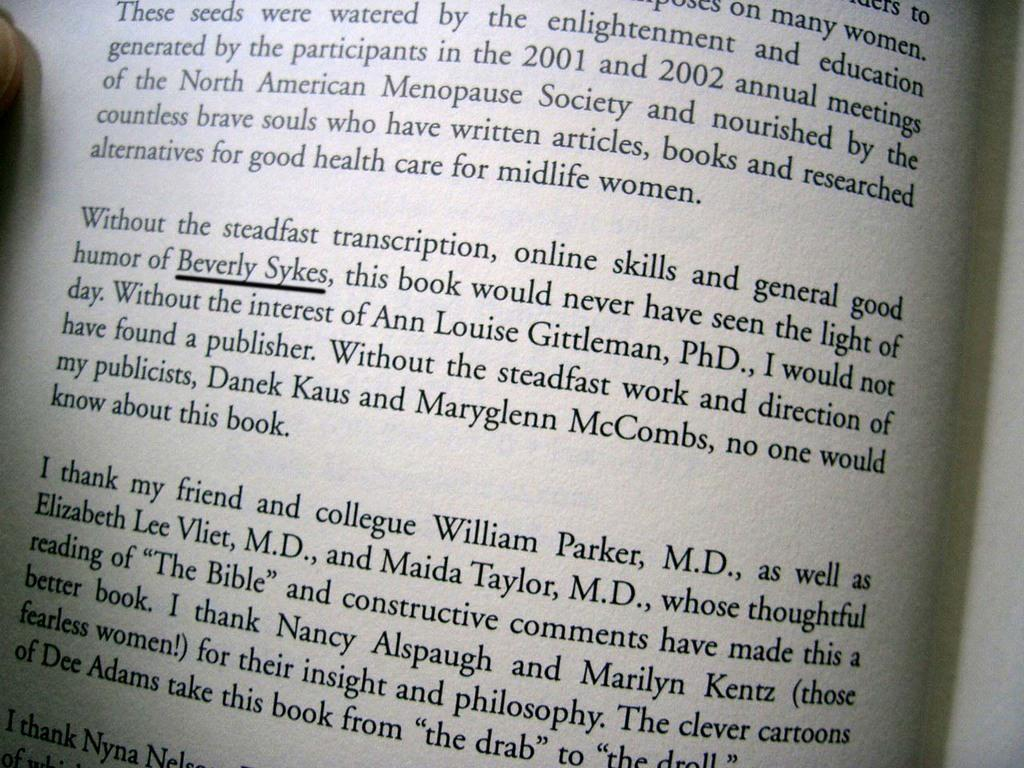<image>
Relay a brief, clear account of the picture shown. A book is opened to a page that has Beverly Sykes underlined in black. 